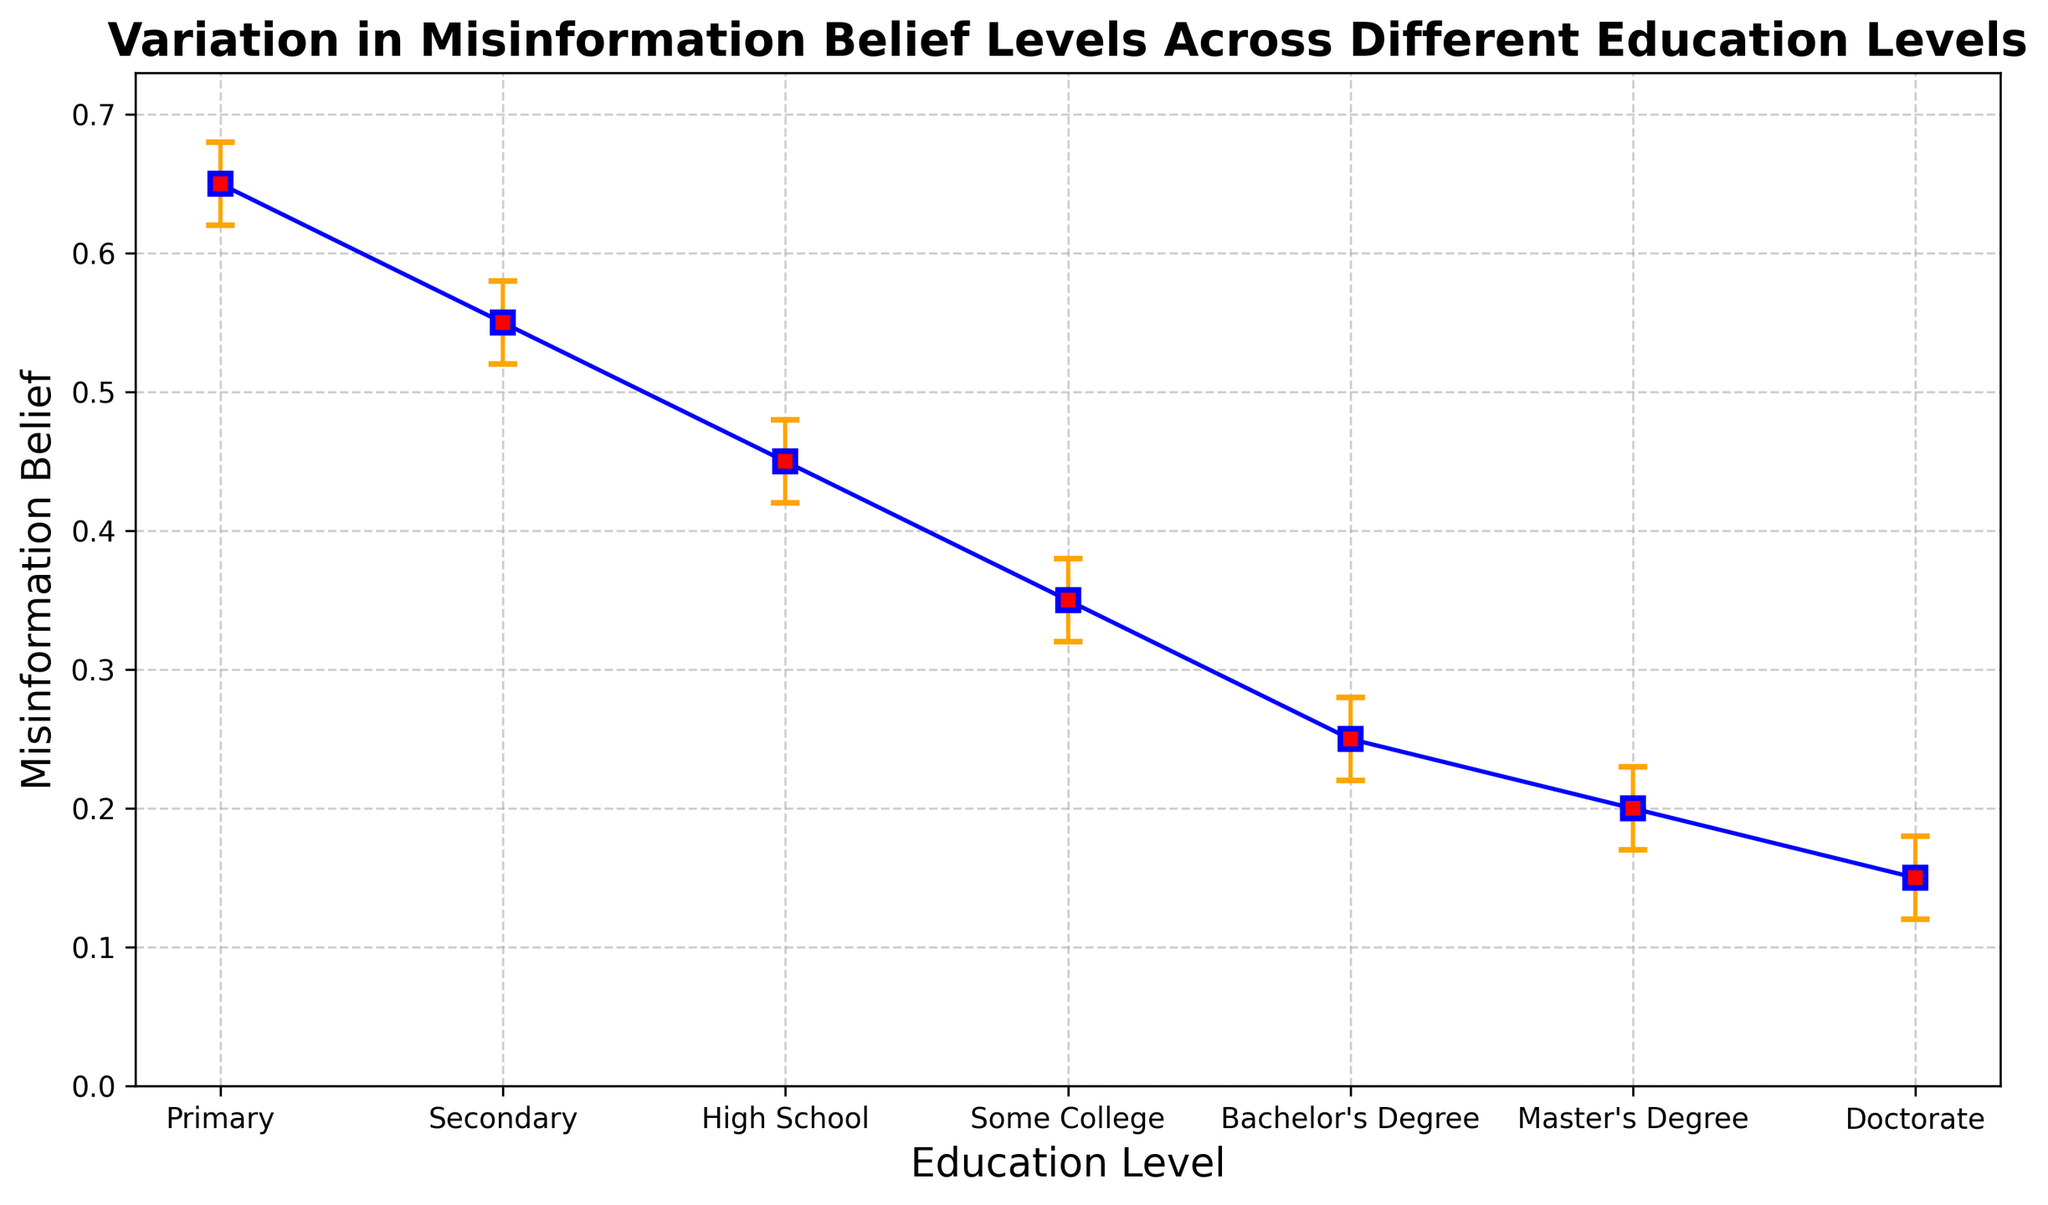What's the misinformation belief level for individuals with a Master's Degree? Look at the point corresponding to "Master's Degree" on the x-axis and read the y-value, which is the misinformation belief level.
Answer: 0.20 Which education level shows the most significant belief in misinformation? Find the highest point on the y-axis among all data points and see which education level it corresponds to.
Answer: Primary How does the misinformation belief level change from Primary to High School education levels? Track the y-values for Primary (0.65), Secondary (0.55), and High School (0.45). Notice the declining trend as education levels increase.
Answer: It decreases What is the average misinformation belief level for individuals with a Bachelor's Degree and a Doctorate? Find the misinformation belief levels for Bachelor's Degree (0.25) and Doctorate (0.15), add them (0.25 + 0.15 = 0.40), then divide by 2 for the average (0.40 / 2).
Answer: 0.20 Which two education levels have the closest misinformation belief levels? Compare the y-values for all education levels to find the smallest difference. High School (0.45) and Some College (0.35) are the closest (difference: 0.10).
Answer: High School and Some College What is the range of misinformation belief levels for individuals with Primary education? The range is calculated by subtracting the lower bound of the confidence interval from the upper bound. For Primary, it's 0.68 (upper bound) - 0.62 (lower bound).
Answer: 0.06 Is there any overlap in the confidence intervals between Secondary and High School education levels? Compare the confidence interval ranges for Secondary (0.52 to 0.58) and High School (0.42 to 0.48). Notice that there is no overlap.
Answer: No What is the difference in misinformation belief levels between individuals with Some College and Bachelor's Degree education? Subtract the misinformation belief level for Bachelor's Degree (0.25) from Some College (0.35).
Answer: 0.10 Which education level has the smallest confidence interval range? Compare the confidence interval ranges (upper bound minus lower bound) for all education levels and identify the smallest range. Doctorate has the smallest range (0.18 - 0.12 = 0.06).
Answer: Doctorate How does the confidence interval range for Primary education compare to that for Master's Degree? Calculate the ranges for both: Primary (0.68 - 0.62 = 0.06) and Master's Degree (0.23 - 0.17 = 0.06). They have equal ranges.
Answer: Equal 